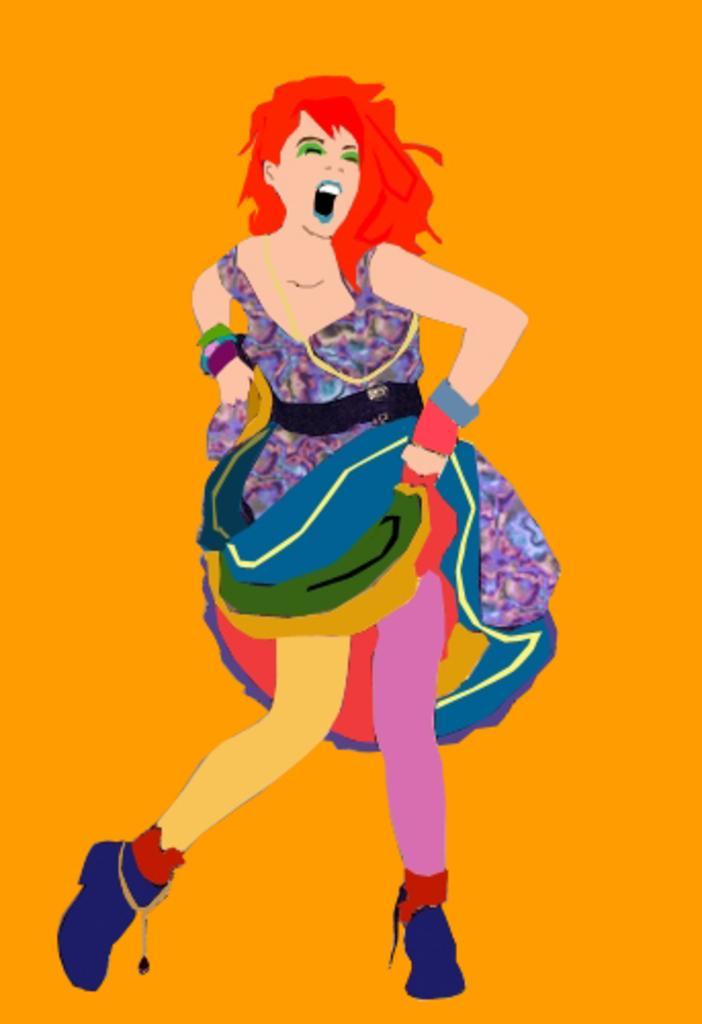How would you summarize this image in a sentence or two? In the center of the image we can see the painting of a lady. In the background we can see orange color. 